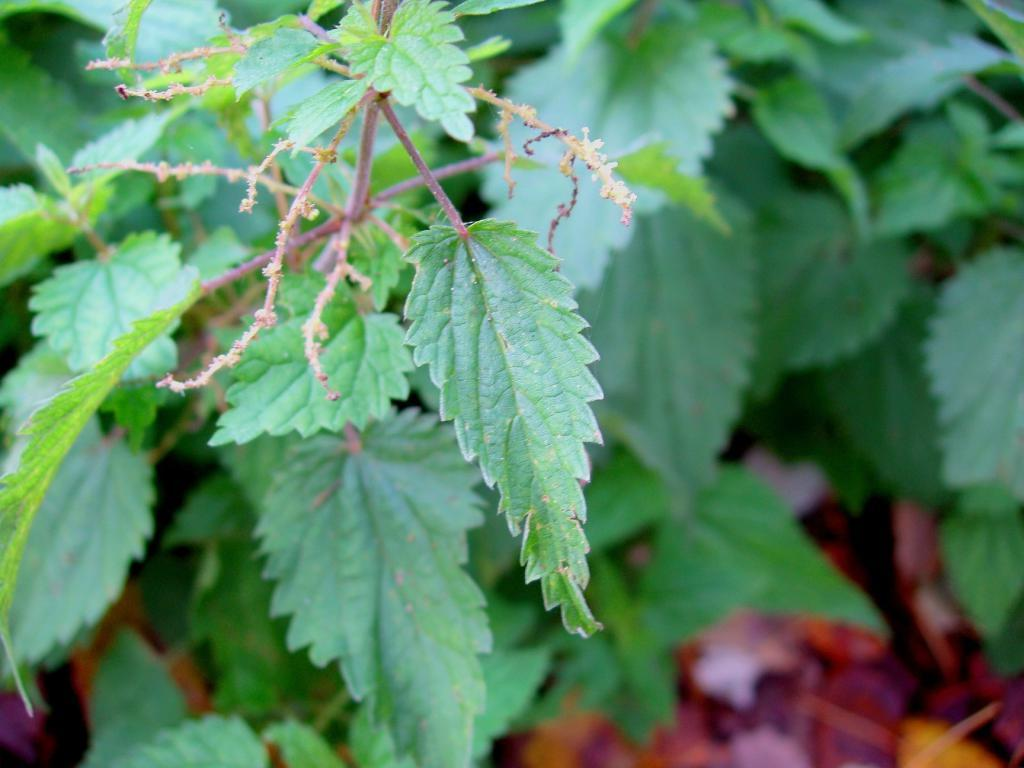What type of vegetation can be seen in the image? There are leaves in the image. What type of locket is hanging from the tree in the image? There is no locket present in the image; it only features leaves. What error can be seen in the image? There is no error present in the image, as it only contains leaves. 